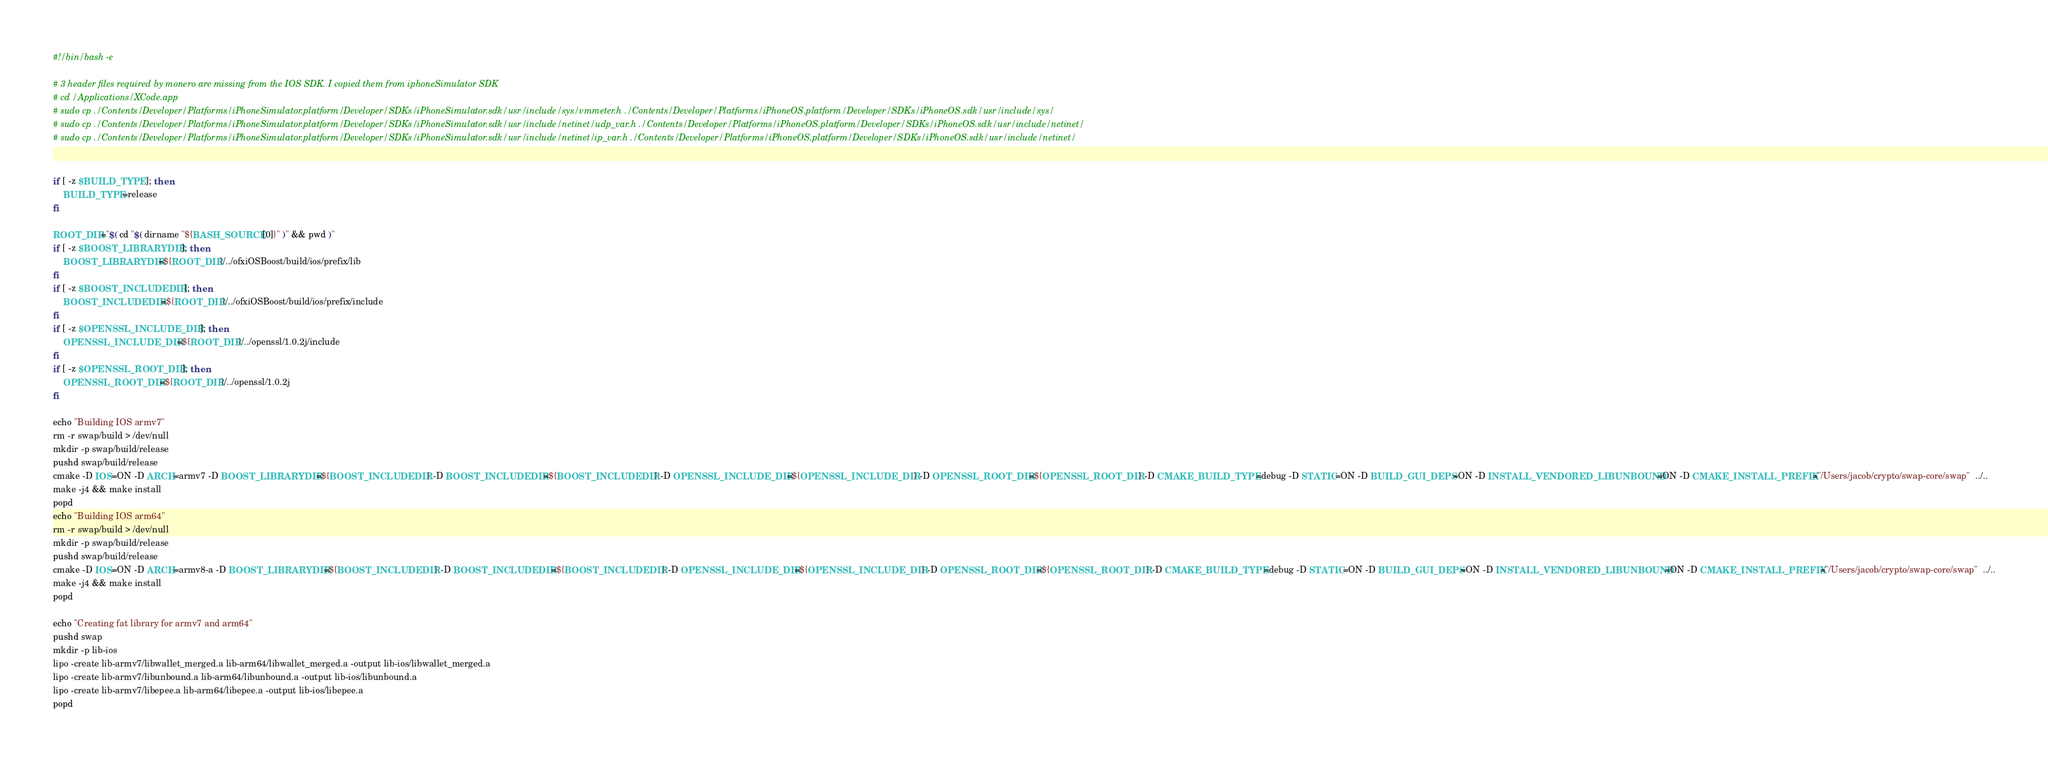Convert code to text. <code><loc_0><loc_0><loc_500><loc_500><_Bash_>#!/bin/bash -e

# 3 header files required by monero are missing from the IOS SDK. I copied them from iphoneSimulator SDK
# cd /Applications/XCode.app
# sudo cp ./Contents/Developer/Platforms/iPhoneSimulator.platform/Developer/SDKs/iPhoneSimulator.sdk/usr/include/sys/vmmeter.h ./Contents/Developer/Platforms/iPhoneOS.platform/Developer/SDKs/iPhoneOS.sdk/usr/include/sys/
# sudo cp ./Contents/Developer/Platforms/iPhoneSimulator.platform/Developer/SDKs/iPhoneSimulator.sdk/usr/include/netinet/udp_var.h ./Contents/Developer/Platforms/iPhoneOS.platform/Developer/SDKs/iPhoneOS.sdk/usr/include/netinet/
# sudo cp ./Contents/Developer/Platforms/iPhoneSimulator.platform/Developer/SDKs/iPhoneSimulator.sdk/usr/include/netinet/ip_var.h ./Contents/Developer/Platforms/iPhoneOS.platform/Developer/SDKs/iPhoneOS.sdk/usr/include/netinet/


if [ -z $BUILD_TYPE ]; then
    BUILD_TYPE=release
fi

ROOT_DIR="$( cd "$( dirname "${BASH_SOURCE[0]}" )" && pwd )"
if [ -z $BOOST_LIBRARYDIR ]; then
    BOOST_LIBRARYDIR=${ROOT_DIR}/../ofxiOSBoost/build/ios/prefix/lib
fi
if [ -z $BOOST_INCLUDEDIR ]; then
    BOOST_INCLUDEDIR=${ROOT_DIR}/../ofxiOSBoost/build/ios/prefix/include
fi
if [ -z $OPENSSL_INCLUDE_DIR ]; then
    OPENSSL_INCLUDE_DIR=${ROOT_DIR}/../openssl/1.0.2j/include
fi
if [ -z $OPENSSL_ROOT_DIR ]; then
    OPENSSL_ROOT_DIR=${ROOT_DIR}/../openssl/1.0.2j
fi

echo "Building IOS armv7"
rm -r swap/build > /dev/null
mkdir -p swap/build/release
pushd swap/build/release
cmake -D IOS=ON -D ARCH=armv7 -D BOOST_LIBRARYDIR=${BOOST_INCLUDEDIR} -D BOOST_INCLUDEDIR=${BOOST_INCLUDEDIR} -D OPENSSL_INCLUDE_DIR=${OPENSSL_INCLUDE_DIR} -D OPENSSL_ROOT_DIR=${OPENSSL_ROOT_DIR} -D CMAKE_BUILD_TYPE=debug -D STATIC=ON -D BUILD_GUI_DEPS=ON -D INSTALL_VENDORED_LIBUNBOUND=ON -D CMAKE_INSTALL_PREFIX="/Users/jacob/crypto/swap-core/swap"  ../..
make -j4 && make install
popd
echo "Building IOS arm64"
rm -r swap/build > /dev/null
mkdir -p swap/build/release
pushd swap/build/release
cmake -D IOS=ON -D ARCH=armv8-a -D BOOST_LIBRARYDIR=${BOOST_INCLUDEDIR} -D BOOST_INCLUDEDIR=${BOOST_INCLUDEDIR} -D OPENSSL_INCLUDE_DIR=${OPENSSL_INCLUDE_DIR} -D OPENSSL_ROOT_DIR=${OPENSSL_ROOT_DIR} -D CMAKE_BUILD_TYPE=debug -D STATIC=ON -D BUILD_GUI_DEPS=ON -D INSTALL_VENDORED_LIBUNBOUND=ON -D CMAKE_INSTALL_PREFIX="/Users/jacob/crypto/swap-core/swap"  ../..
make -j4 && make install
popd

echo "Creating fat library for armv7 and arm64"
pushd swap
mkdir -p lib-ios
lipo -create lib-armv7/libwallet_merged.a lib-arm64/libwallet_merged.a -output lib-ios/libwallet_merged.a
lipo -create lib-armv7/libunbound.a lib-arm64/libunbound.a -output lib-ios/libunbound.a
lipo -create lib-armv7/libepee.a lib-arm64/libepee.a -output lib-ios/libepee.a
popd
</code> 